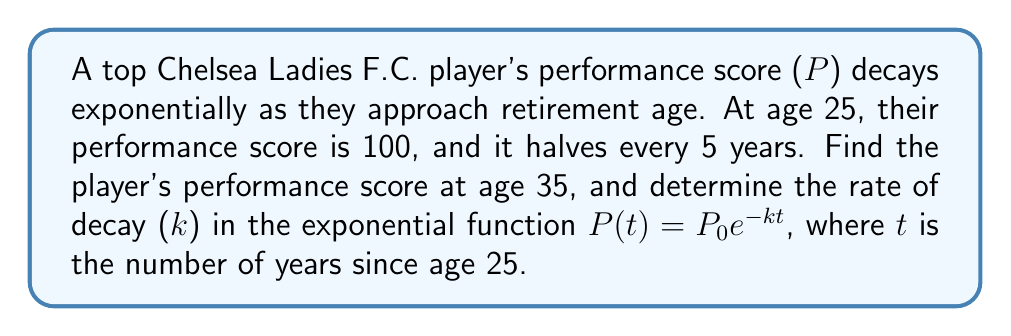Teach me how to tackle this problem. 1) First, let's set up the exponential decay function:
   $P(t) = P_0e^{-kt}$
   where $P_0 = 100$ (initial performance at age 25)

2) We know that the performance halves every 5 years. This means:
   $P(5) = 50 = 100e^{-5k}$

3) Solving for k:
   $\frac{1}{2} = e^{-5k}$
   $\ln(\frac{1}{2}) = -5k$
   $k = -\frac{\ln(\frac{1}{2})}{5} = \frac{\ln(2)}{5}$

4) Now that we have k, we can find the performance at age 35:
   $t = 35 - 25 = 10$ years since age 25
   $P(10) = 100e^{-\frac{\ln(2)}{5} \cdot 10}$
   $= 100e^{-2\ln(2)}$
   $= 100 \cdot (\frac{1}{2})^2$
   $= 100 \cdot \frac{1}{4} = 25$

Therefore, the player's performance score at age 35 is 25, and the rate of decay k is $\frac{\ln(2)}{5}$.
Answer: Performance at age 35: 25; Decay rate $k = \frac{\ln(2)}{5}$ 